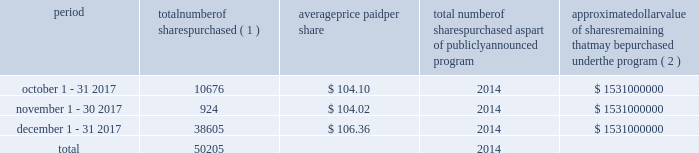Table of contents celanese purchases of its equity securities information regarding repurchases of our common stock during the three months ended december 31 , 2017 is as follows : period number of shares purchased ( 1 ) average price paid per share total number of shares purchased as part of publicly announced program approximate dollar value of shares remaining that may be purchased under the program ( 2 ) .
___________________________ ( 1 ) represents shares withheld from employees to cover their statutory minimum withholding requirements for personal income taxes related to the vesting of restricted stock units .
( 2 ) our board of directors has authorized the aggregate repurchase of $ 3.9 billion of our common stock since february 2008 , including an increase of $ 1.5 billion on july 17 , 2017 .
See note 17 - stockholders' equity in the accompanying consolidated financial statements for further information. .
What was the percent of the number of shares purchased in october 1 - 31 2017 as part of the 2017 total? 
Computations: (10676 / 50205)
Answer: 0.21265. Table of contents celanese purchases of its equity securities information regarding repurchases of our common stock during the three months ended december 31 , 2017 is as follows : period number of shares purchased ( 1 ) average price paid per share total number of shares purchased as part of publicly announced program approximate dollar value of shares remaining that may be purchased under the program ( 2 ) .
___________________________ ( 1 ) represents shares withheld from employees to cover their statutory minimum withholding requirements for personal income taxes related to the vesting of restricted stock units .
( 2 ) our board of directors has authorized the aggregate repurchase of $ 3.9 billion of our common stock since february 2008 , including an increase of $ 1.5 billion on july 17 , 2017 .
See note 17 - stockholders' equity in the accompanying consolidated financial statements for further information. .
What is the total value of purchased shares during october 2017 , in millions? 
Computations: ((10676 * 104.10) / 1000000)
Answer: 1.11137. 